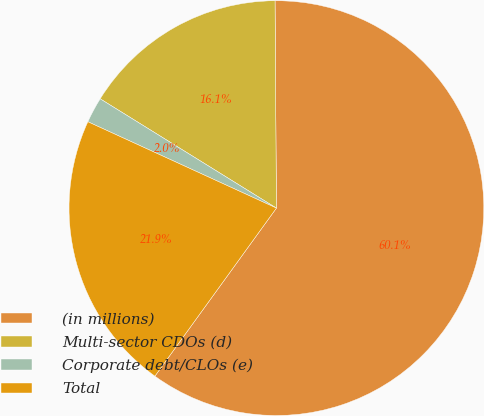Convert chart to OTSL. <chart><loc_0><loc_0><loc_500><loc_500><pie_chart><fcel>(in millions)<fcel>Multi-sector CDOs (d)<fcel>Corporate debt/CLOs (e)<fcel>Total<nl><fcel>60.07%<fcel>16.06%<fcel>2.0%<fcel>21.87%<nl></chart> 